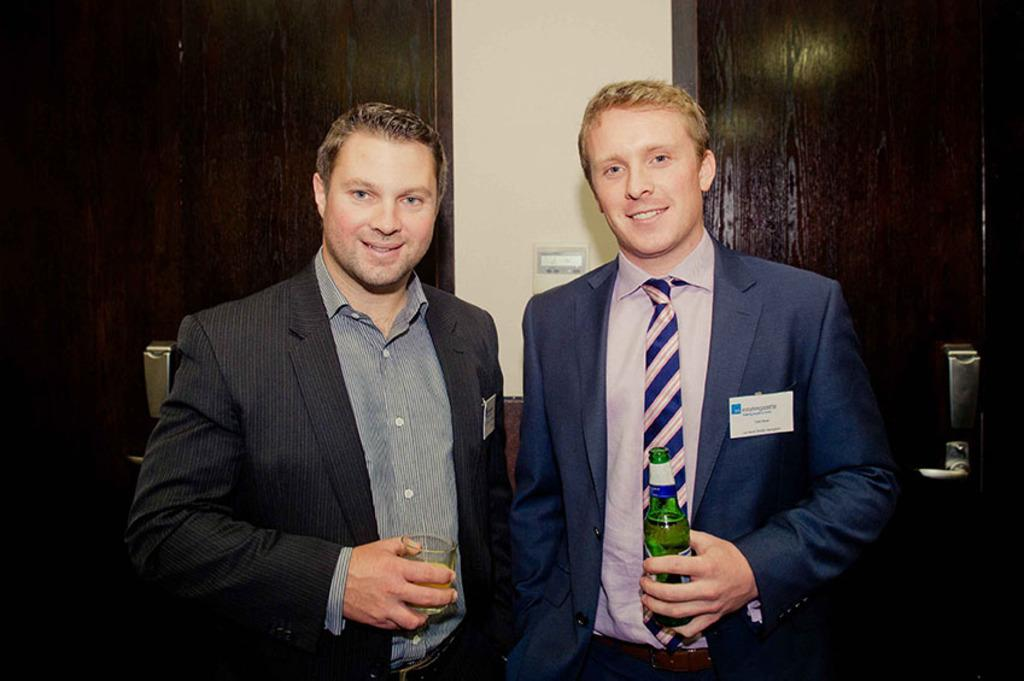How many people are in the image? There are two men in the image. What expressions do the men have? Both men are smiling. What type of clothing are the men wearing? The men are wearing coats. What can be seen in the background of the image? There are doors visible in the background. What type of star can be seen in the image? There is no star present in the image. What is inside the box that the men are holding in the image? There is no box or any object being held by the men in the image. 